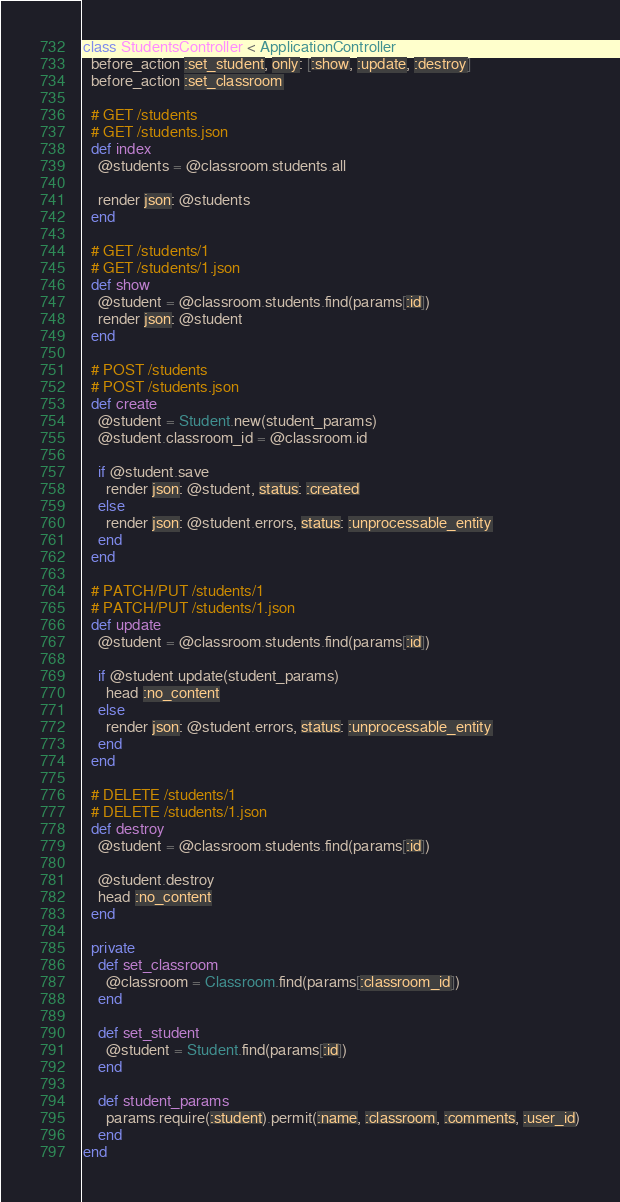Convert code to text. <code><loc_0><loc_0><loc_500><loc_500><_Ruby_>class StudentsController < ApplicationController
  before_action :set_student, only: [:show, :update, :destroy]
  before_action :set_classroom

  # GET /students
  # GET /students.json
  def index
    @students = @classroom.students.all

    render json: @students
  end

  # GET /students/1
  # GET /students/1.json
  def show
    @student = @classroom.students.find(params[:id])
    render json: @student
  end

  # POST /students
  # POST /students.json
  def create
    @student = Student.new(student_params)
    @student.classroom_id = @classroom.id

    if @student.save
      render json: @student, status: :created
    else
      render json: @student.errors, status: :unprocessable_entity
    end
  end

  # PATCH/PUT /students/1
  # PATCH/PUT /students/1.json
  def update
    @student = @classroom.students.find(params[:id])

    if @student.update(student_params)
      head :no_content
    else
      render json: @student.errors, status: :unprocessable_entity
    end
  end

  # DELETE /students/1
  # DELETE /students/1.json
  def destroy
    @student = @classroom.students.find(params[:id])

    @student.destroy
    head :no_content
  end

  private
    def set_classroom
      @classroom = Classroom.find(params[:classroom_id])
    end

    def set_student
      @student = Student.find(params[:id])
    end

    def student_params
      params.require(:student).permit(:name, :classroom, :comments, :user_id)
    end
end
</code> 